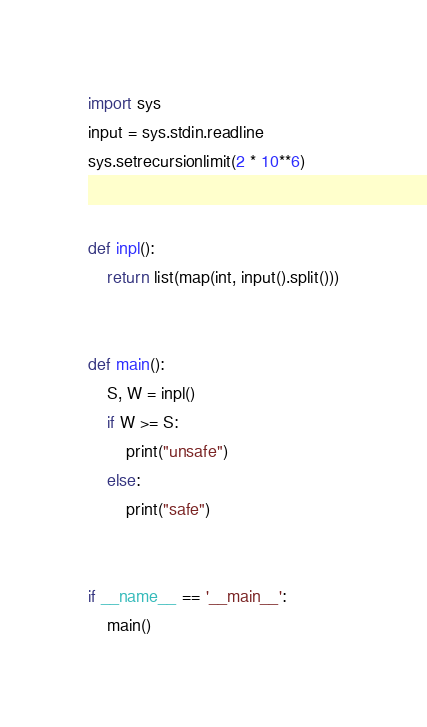<code> <loc_0><loc_0><loc_500><loc_500><_Python_>import sys
input = sys.stdin.readline
sys.setrecursionlimit(2 * 10**6)


def inpl():
    return list(map(int, input().split()))


def main():
    S, W = inpl()
    if W >= S:
        print("unsafe")
    else:
        print("safe")


if __name__ == '__main__':
    main()
</code> 